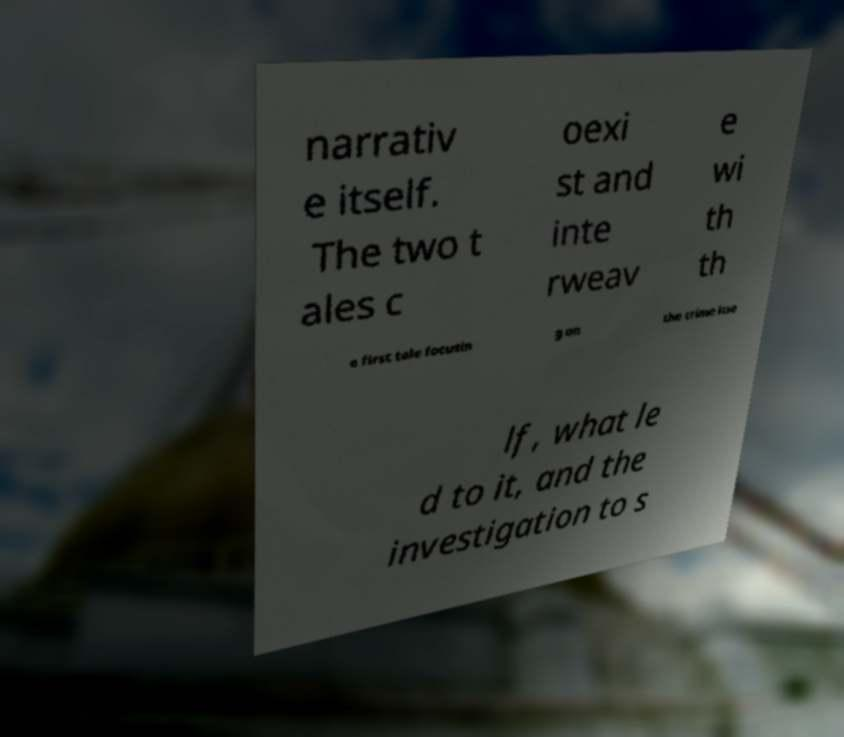Could you extract and type out the text from this image? narrativ e itself. The two t ales c oexi st and inte rweav e wi th th e first tale focusin g on the crime itse lf, what le d to it, and the investigation to s 